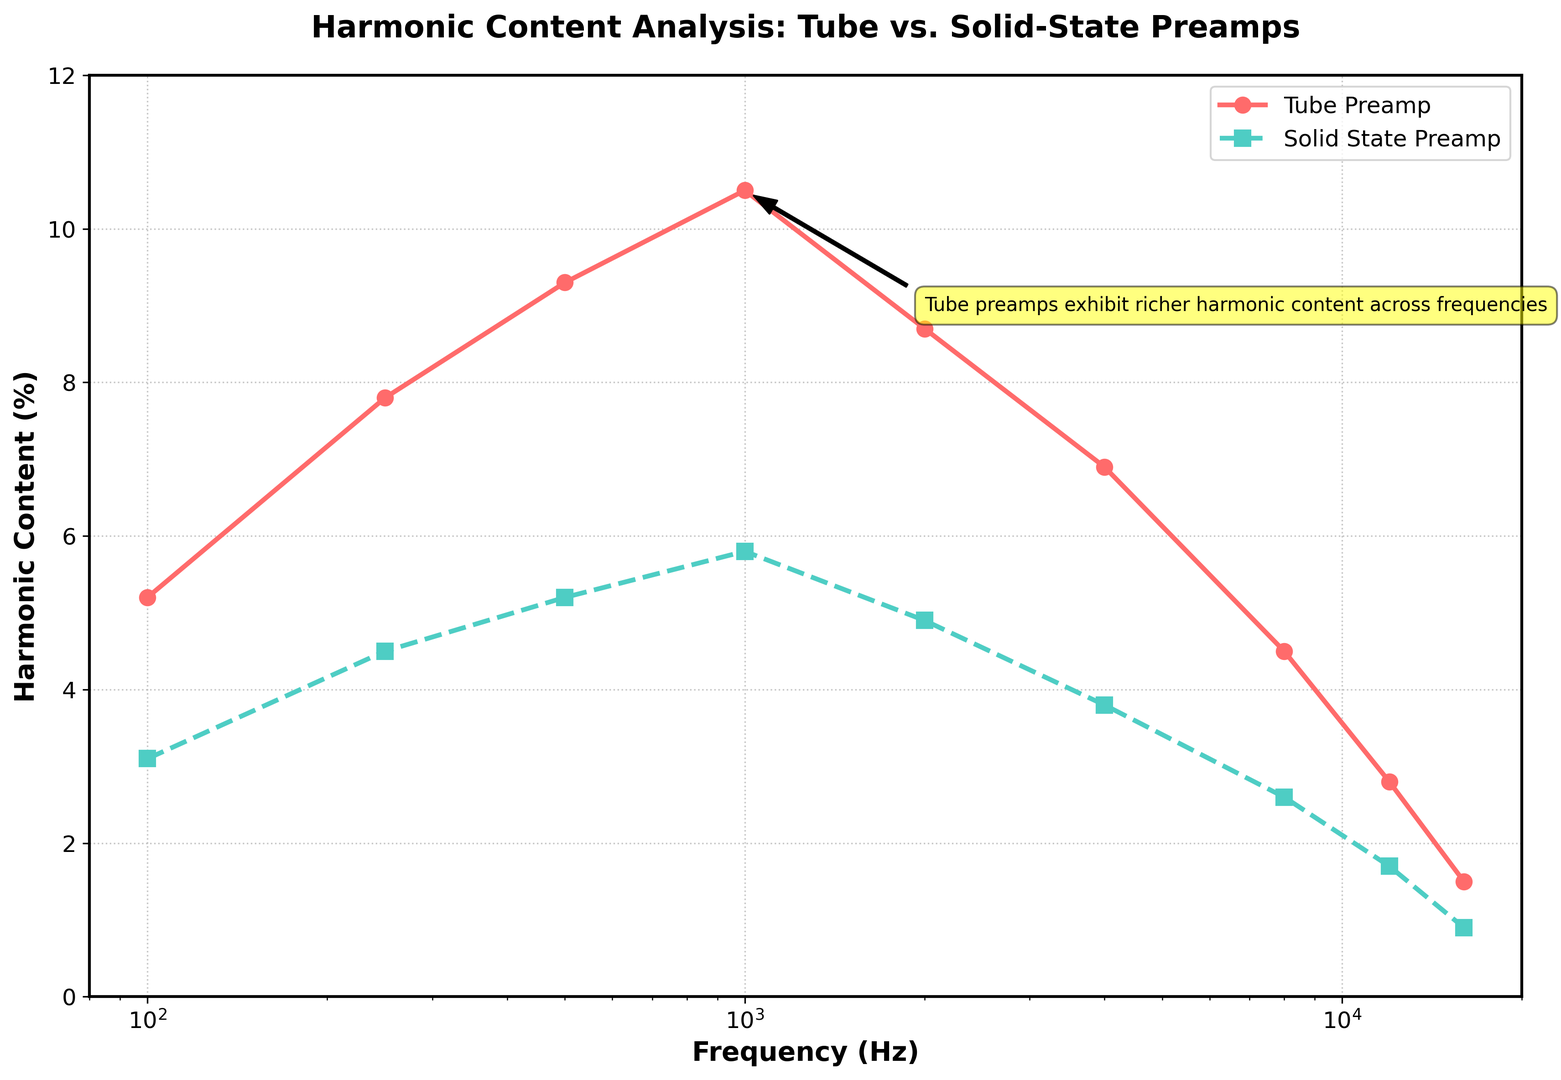What's the harmonic content of the tube preamp at 1000 Hz? The plot indicates that the harmonic content of the tube preamp at 1000 Hz is marked by the height of the red line, which is labeled at this point.
Answer: 10.5% How does the harmonic content of the tube preamp compare to the solid-state preamp at 500 Hz? The red line (tube preamp) at 500 Hz is at 9.3%, while the cyan dashed line (solid-state preamp) at the same frequency is at 5.2%. By comparing the two values, 9.3% is greater than 5.2%.
Answer: Tube preamp has more harmonic content What is the difference in harmonic content between the tube and solid-state preamps at 8000 Hz? The tube preamp's harmonic content at 8000 Hz is 4.5%, and that of the solid-state preamp is 2.6%. The difference is calculated by subtracting 2.6% from 4.5%.
Answer: 1.9% At what frequency do both preamps have the lowest harmonic content values and what are these values? The lowest harmonic content for both preamps occurs at 16000 Hz. The tube preamp's value is 1.5%, while the solid-state preamp's value is 0.9%.
Answer: 16000 Hz, tube: 1.5%, solid-state: 0.9% What does the annotation in the plot state about the harmonic content? The annotation on the plot, located around the 1000 Hz frequency mark, states that "Tube preamps exhibit richer harmonic content across frequencies," which summarizes the overall higher harmonic levels of tube preamps compared to solid-state preamps.
Answer: Tube preamps exhibit richer harmonic content across frequencies Is there any frequency where the solid-state preamp has more harmonic content than the tube preamp? By examining the plot, we observe that the red line (tube) is consistently above the cyan dashed line (solid-state) at all frequencies, indicating that the solid-state preamp never exceeds the tube preamp in harmonic content at any measured frequency.
Answer: No What is the average harmonic content for the tube preamp across all frequencies? To calculate the average harmonic content for the tube preamp, sum all the provided values (5.2, 7.8, 9.3, 10.5, 8.7, 6.9, 4.5, 2.8, 1.5) and divide by the number of data points (9). (5.2 + 7.8 + 9.3 + 10.5 + 8.7 + 6.9 + 4.5 + 2.8 + 1.5) / 9 = 57.2 / 9 ≈ 6.36
Answer: 6.36% 